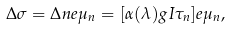<formula> <loc_0><loc_0><loc_500><loc_500>\Delta \sigma = \Delta n e \mu _ { n } = [ \alpha ( \lambda ) g I \tau _ { n } ] e \mu _ { n } ,</formula> 